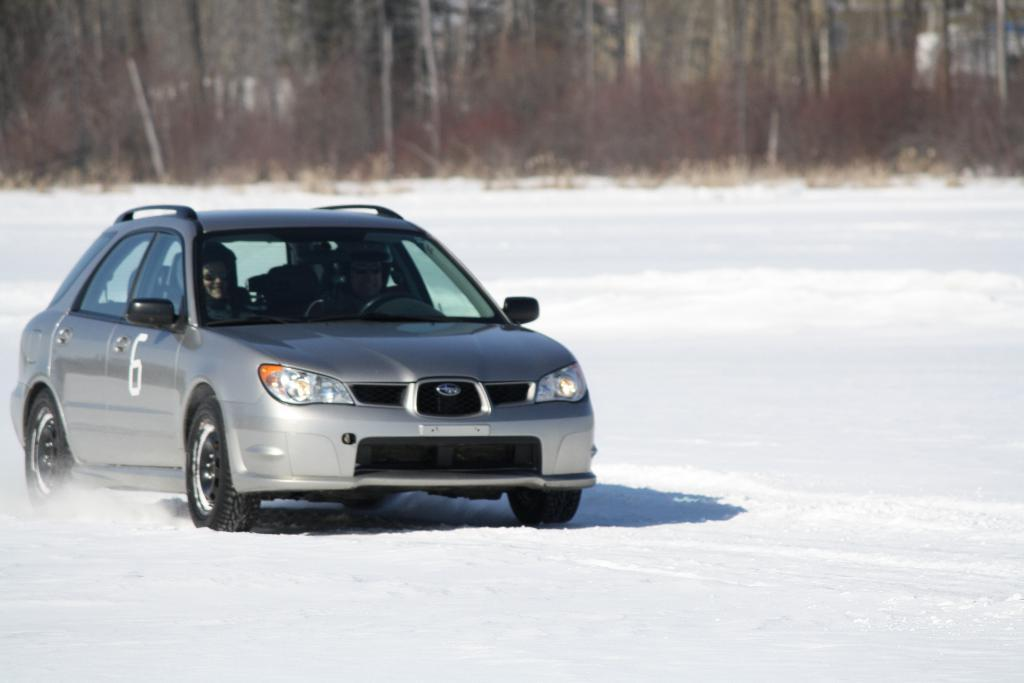What is happening on the left side of the image? There is a person riding a vehicle on the left side of the image. What color is the vehicle? The vehicle is gray in color. What can be seen on the vehicle? There is a painting of a number six on the vehicle. What is the surface the vehicle is on? The vehicle is on a snowy surface. What can be seen in the background of the image? There are trees in the background of the image. What type of coil is being used to scale the vehicle in the image? There is no coil or scaling activity present in the image; it features a person riding a vehicle with a number six painting on a snowy surface. How many bites does the person take out of the vehicle in the image? There is no indication of the person biting the vehicle in the image. 